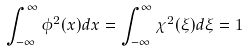<formula> <loc_0><loc_0><loc_500><loc_500>\int _ { - \infty } ^ { \infty } \phi ^ { 2 } ( x ) d x = \int _ { - \infty } ^ { \infty } \chi ^ { 2 } ( \xi ) d \xi = 1</formula> 